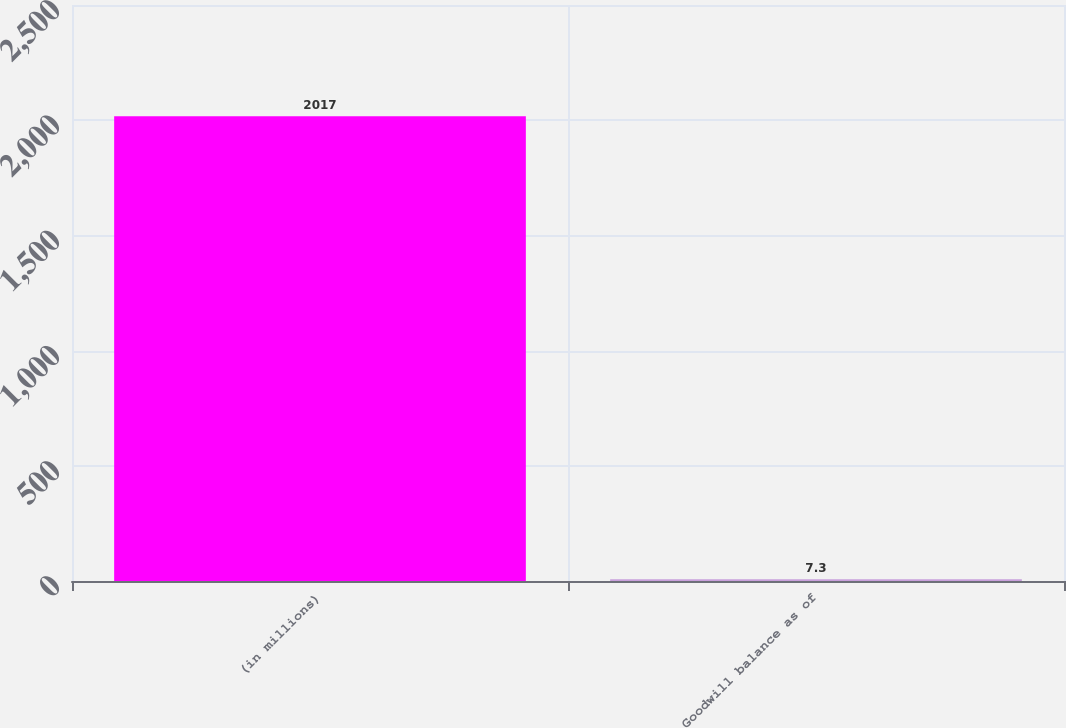<chart> <loc_0><loc_0><loc_500><loc_500><bar_chart><fcel>(in millions)<fcel>Goodwill balance as of<nl><fcel>2017<fcel>7.3<nl></chart> 